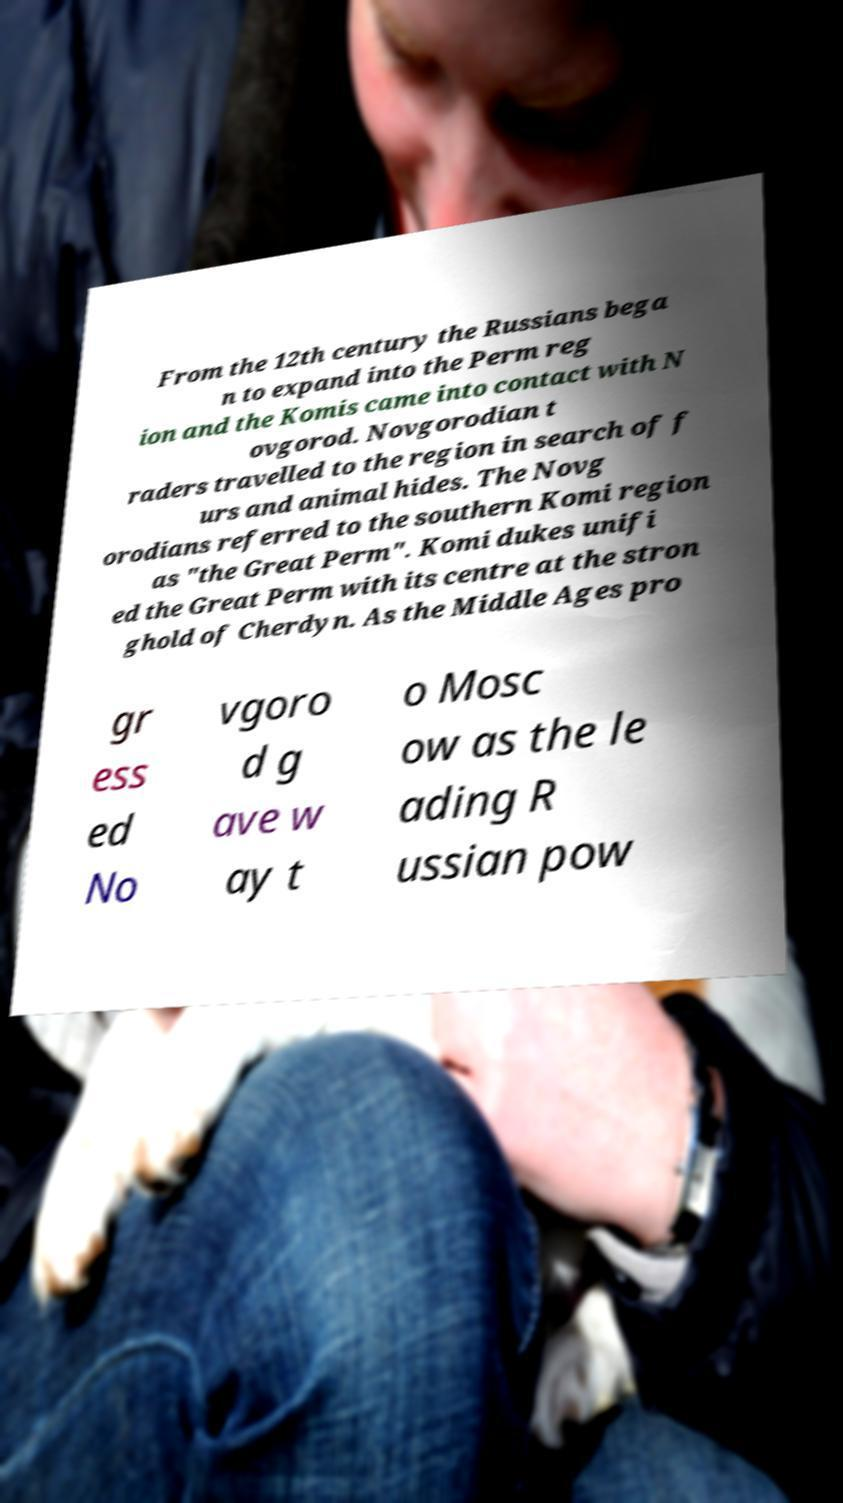Could you assist in decoding the text presented in this image and type it out clearly? From the 12th century the Russians bega n to expand into the Perm reg ion and the Komis came into contact with N ovgorod. Novgorodian t raders travelled to the region in search of f urs and animal hides. The Novg orodians referred to the southern Komi region as "the Great Perm". Komi dukes unifi ed the Great Perm with its centre at the stron ghold of Cherdyn. As the Middle Ages pro gr ess ed No vgoro d g ave w ay t o Mosc ow as the le ading R ussian pow 